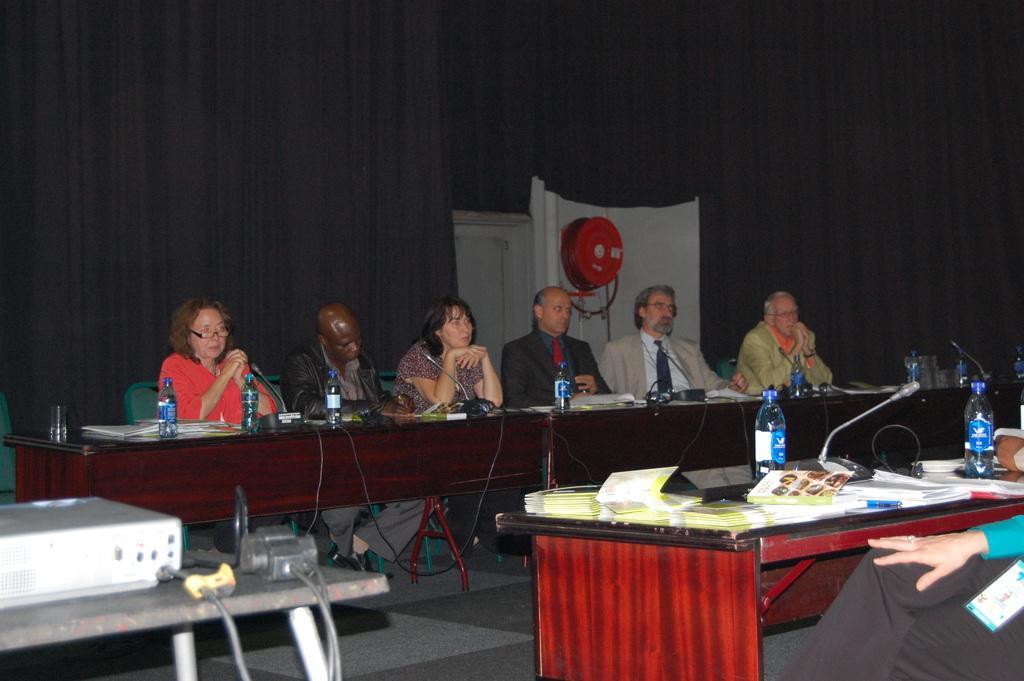Please provide a concise description of this image. This picture we can see some people are sitting on the chair in front of them there is a table on the table we have bottles plate glasses papers in opposite we can see another table on the table we have water bottles paper and microphones. 